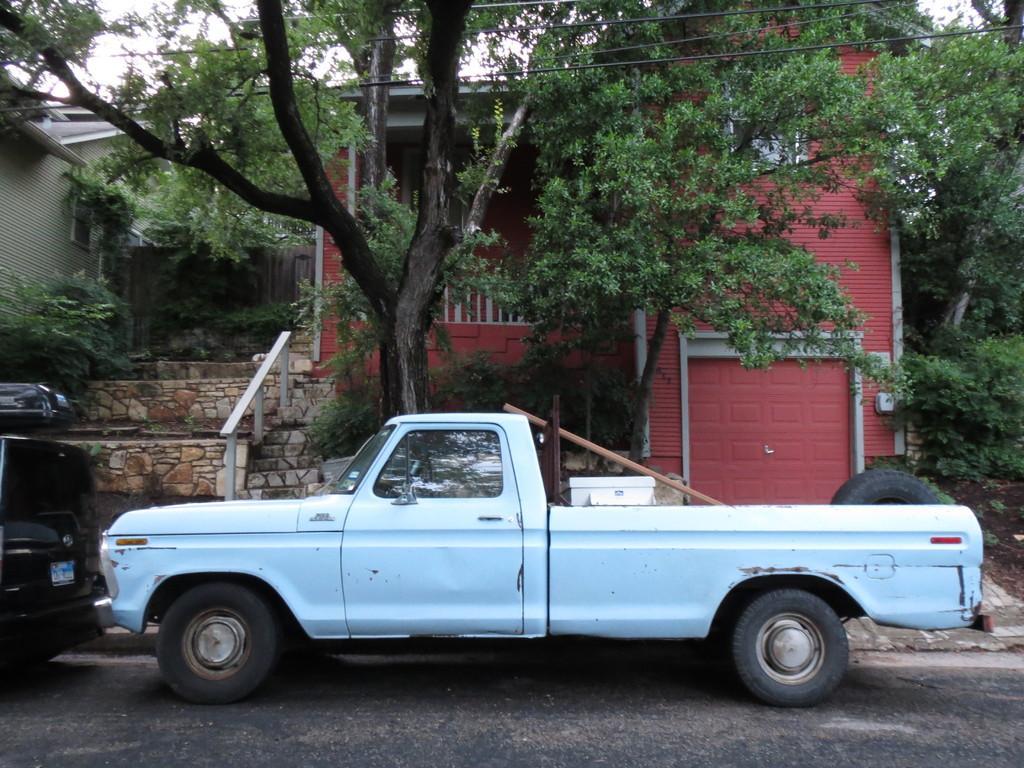Can you describe this image briefly? In this picture we can see few vehicles on the road, in the background we can see few trees, buildings and cables, and also we can see a tyre and other things in the truck. 